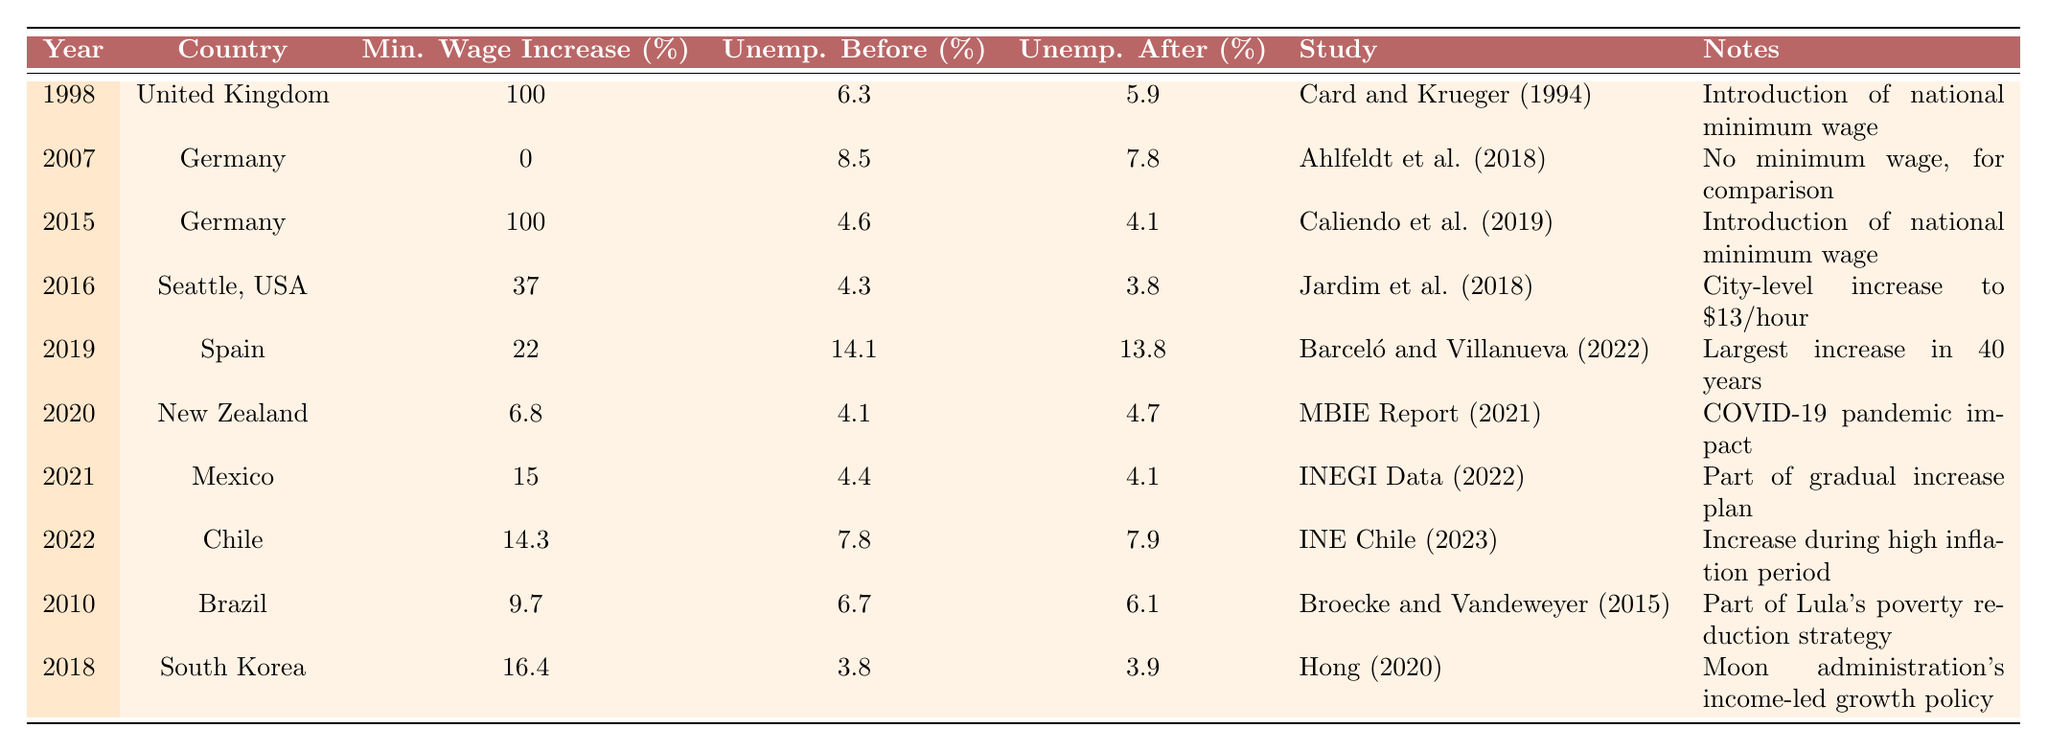What was the minimum wage increase percentage in the United Kingdom in 1998? The table lists the United Kingdom in 1998 with a minimum wage increase of 100%.
Answer: 100% What was the unemployment rate in Chile before the 2022 minimum wage increase? Looking at the table, Chile in 2022 had an unemployment rate before the increase of 7.8%.
Answer: 7.8% Which country had the highest unemployment rate after a minimum wage increase in this table? Upon reviewing the data, Spain had the highest unemployment rate after the increase, at 13.8%.
Answer: Spain What was the average unemployment rate before the minimum wage increases across all countries listed in the table? Adding the unemployment rates before the increases: 6.3 + 8.5 + 4.6 + 4.3 + 14.1 + 4.1 + 4.4 + 7.8 + 6.7 + 3.8 = 58.7. There are 10 data points, so the average is 58.7 / 10 = 5.87%.
Answer: 5.87% Did the introduction of a national minimum wage in Germany in 2015 lower the unemployment rate? The unemployment rate before the minimum wage was 4.6%, and after it was 4.1%, showing a decrease.
Answer: Yes What is the difference in unemployment rates before and after the minimum wage increase in Seattle, USA? The unemployment rate before the increase was 4.3%, and after it was 3.8%, giving a difference of 4.3 - 3.8 = 0.5%.
Answer: 0.5% Which study reported the introduction of a national minimum wage in Brazil and what was the increase percentage? The study referenced is "Broecke and Vandeweyer (2015)" and the minimum wage increase percentage was 9.7%.
Answer: Broecke and Vandeweyer (2015), 9.7% Was there a decrease in unemployment rates in all cases listed in the table after minimum wage increases? Analyzing the data, all cases with minimum wage increases showed a decrease in unemployment rates except for Chile, where it increased.
Answer: No Considering all listed minimum wage increases, which one had the smallest impact on unemployment rate? The smallest percent decrease is in the case of Chile, where the unemployment rate increased from 7.8% to 7.9%, showing no positive impact.
Answer: Chile What was the total minimum wage increase percentage across all countries in the table? The total is calculated by adding: 100 + 0 + 100 + 37 + 22 + 6.8 + 15 + 14.3 + 9.7 + 16.4 = 311.2%.
Answer: 311.2% 